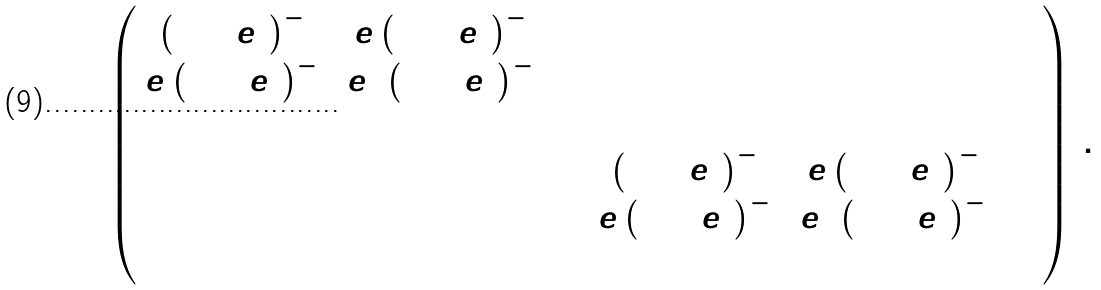<formula> <loc_0><loc_0><loc_500><loc_500>\Lambda = \left ( \begin{array} { c c c c c c } { { \left ( 1 + e ^ { 2 } \right ) ^ { - 1 } } } & { { e \left ( 1 + e ^ { 2 } \right ) ^ { - 1 } } } & { 0 } & { 0 } & { 0 } & { 0 } \\ { { e \left ( 1 + e ^ { 2 } \right ) ^ { - 1 } } } & { { e ^ { 2 } \left ( 1 + e ^ { 2 } \right ) ^ { - 1 } } } & { 0 } & { 0 } & { 0 } & { 0 } \\ { 0 } & { 0 } & { 0 } & { 0 } & { 0 } & { 0 } \\ { 0 } & { 0 } & { 0 } & { { \left ( 1 + e ^ { 2 } \right ) ^ { - 1 } } } & { { e \left ( 1 + e ^ { 2 } \right ) ^ { - 1 } } } & { 0 } \\ { 0 } & { 0 } & { 0 } & { { e \left ( 1 + e ^ { 2 } \right ) ^ { - 1 } } } & { { e ^ { 2 } \left ( 1 + e ^ { 2 } \right ) ^ { - 1 } } } & { 0 } \\ { 0 } & { 0 } & { 0 } & { 0 } & { 0 } & { 0 } \end{array} \right ) \, .</formula> 